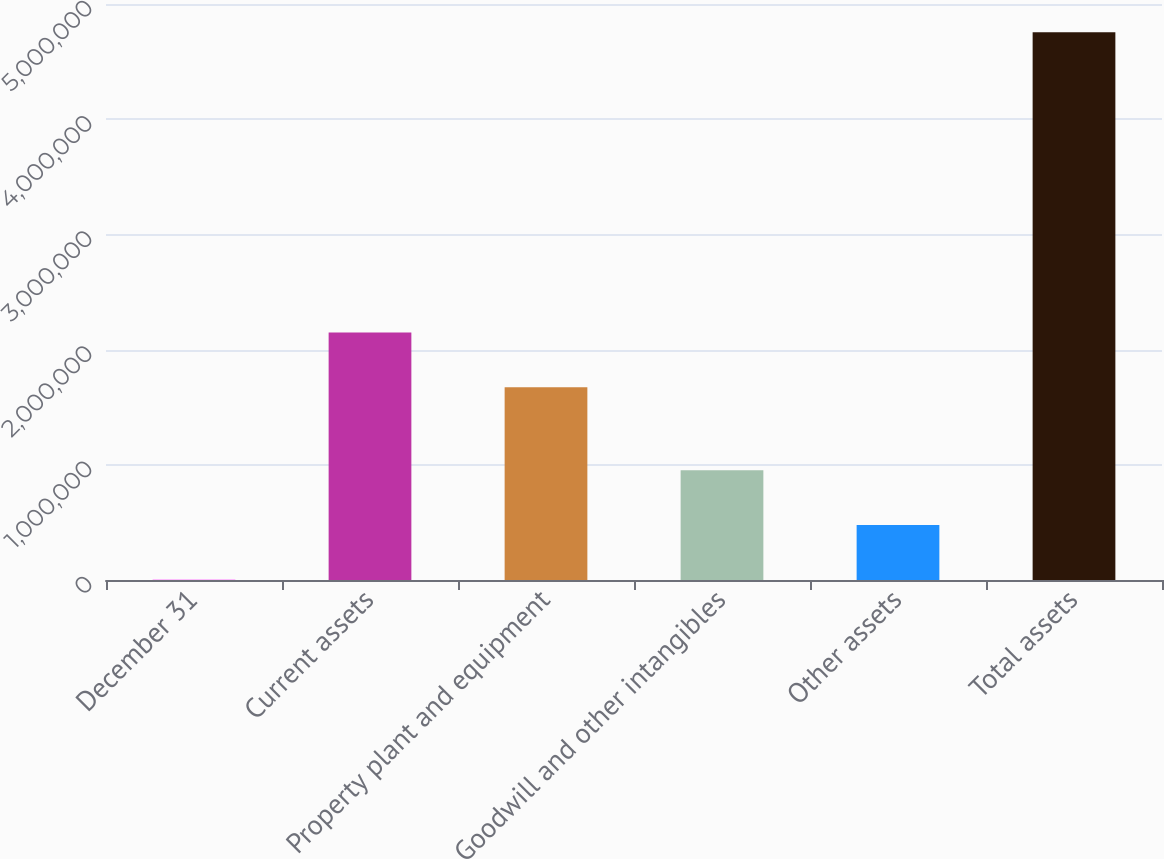Convert chart to OTSL. <chart><loc_0><loc_0><loc_500><loc_500><bar_chart><fcel>December 31<fcel>Current assets<fcel>Property plant and equipment<fcel>Goodwill and other intangibles<fcel>Other assets<fcel>Total assets<nl><fcel>2012<fcel>2.14935e+06<fcel>1.67407e+06<fcel>952577<fcel>477295<fcel>4.75484e+06<nl></chart> 